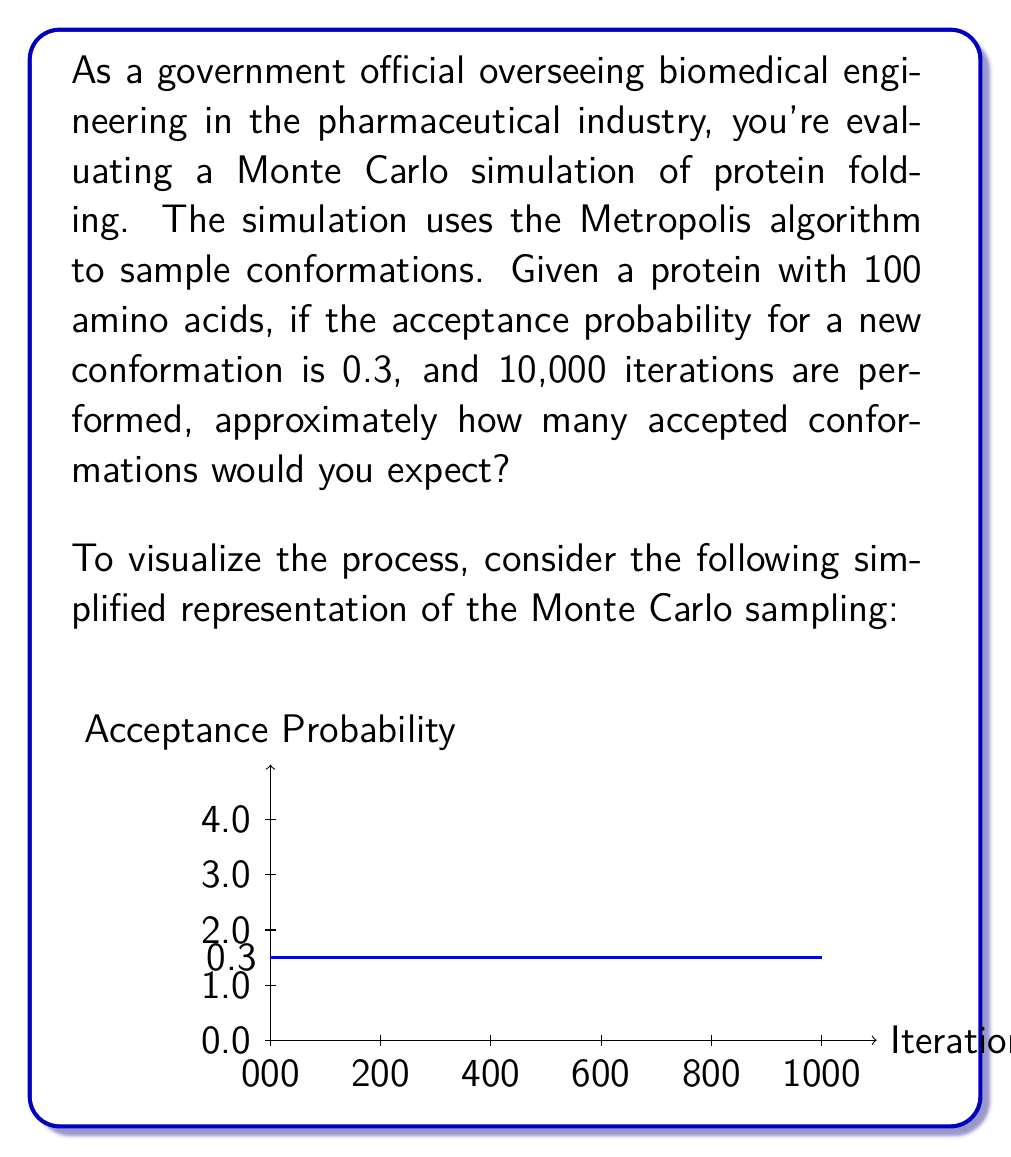Give your solution to this math problem. To solve this problem, we need to follow these steps:

1) Understand the given information:
   - The protein has 100 amino acids
   - The acceptance probability for a new conformation is 0.3
   - The simulation performs 10,000 iterations

2) In Monte Carlo simulations using the Metropolis algorithm, each iteration proposes a new conformation, which is then either accepted or rejected based on the acceptance probability.

3) The expected number of accepted conformations can be calculated using the binomial distribution:

   $$E(X) = n \cdot p$$

   Where:
   $E(X)$ is the expected number of successes (accepted conformations)
   $n$ is the number of trials (iterations)
   $p$ is the probability of success (acceptance probability)

4) Plugging in our values:
   $$E(X) = 10,000 \cdot 0.3 = 3,000$$

5) Therefore, we would expect approximately 3,000 accepted conformations.

This result provides valuable insight into the efficiency of the simulation and the exploration of the protein's conformational space, which is crucial for understanding protein folding processes in pharmaceutical research and development.
Answer: 3,000 accepted conformations 